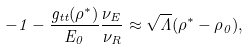<formula> <loc_0><loc_0><loc_500><loc_500>- 1 - \frac { g _ { t t } ( \rho ^ { * } ) } { E _ { 0 } } \frac { \nu _ { E } } { \nu _ { R } } \approx \sqrt { \Lambda } ( \rho ^ { * } - \rho _ { 0 } ) ,</formula> 